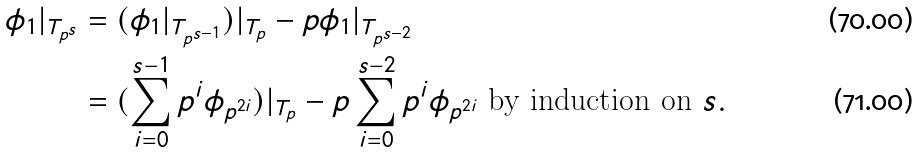<formula> <loc_0><loc_0><loc_500><loc_500>\phi _ { 1 } | _ { T _ { p ^ { s } } } & = ( \phi _ { 1 } | _ { T _ { p ^ { s - 1 } } } ) | _ { T _ { p } } - p \phi _ { 1 } | _ { T _ { p ^ { s - 2 } } } \\ & = ( \sum _ { i = 0 } ^ { s - 1 } p ^ { i } \phi _ { p ^ { 2 i } } ) | _ { T _ { p } } - p \sum _ { i = 0 } ^ { s - 2 } p ^ { i } \phi _ { p ^ { 2 i } } \text { by induction on } s .</formula> 